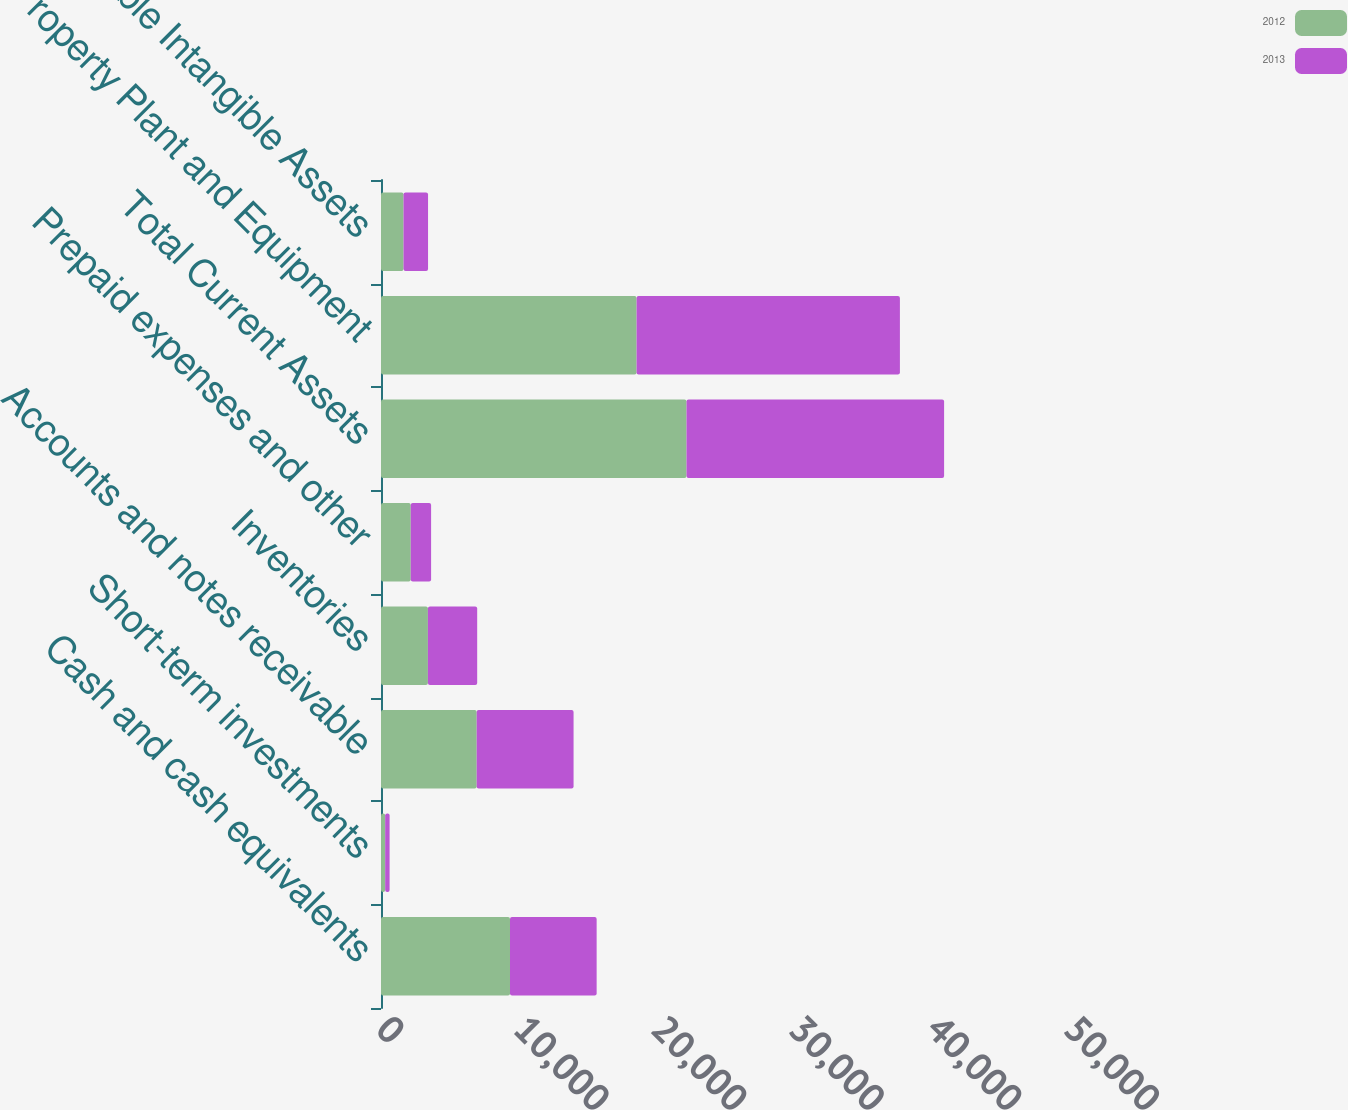Convert chart to OTSL. <chart><loc_0><loc_0><loc_500><loc_500><stacked_bar_chart><ecel><fcel>Cash and cash equivalents<fcel>Short-term investments<fcel>Accounts and notes receivable<fcel>Inventories<fcel>Prepaid expenses and other<fcel>Total Current Assets<fcel>Property Plant and Equipment<fcel>Amortizable Intangible Assets<nl><fcel>2012<fcel>9375<fcel>303<fcel>6954<fcel>3409<fcel>2162<fcel>22203<fcel>18575<fcel>1638<nl><fcel>2013<fcel>6297<fcel>322<fcel>7041<fcel>3581<fcel>1479<fcel>18720<fcel>19136<fcel>1781<nl></chart> 